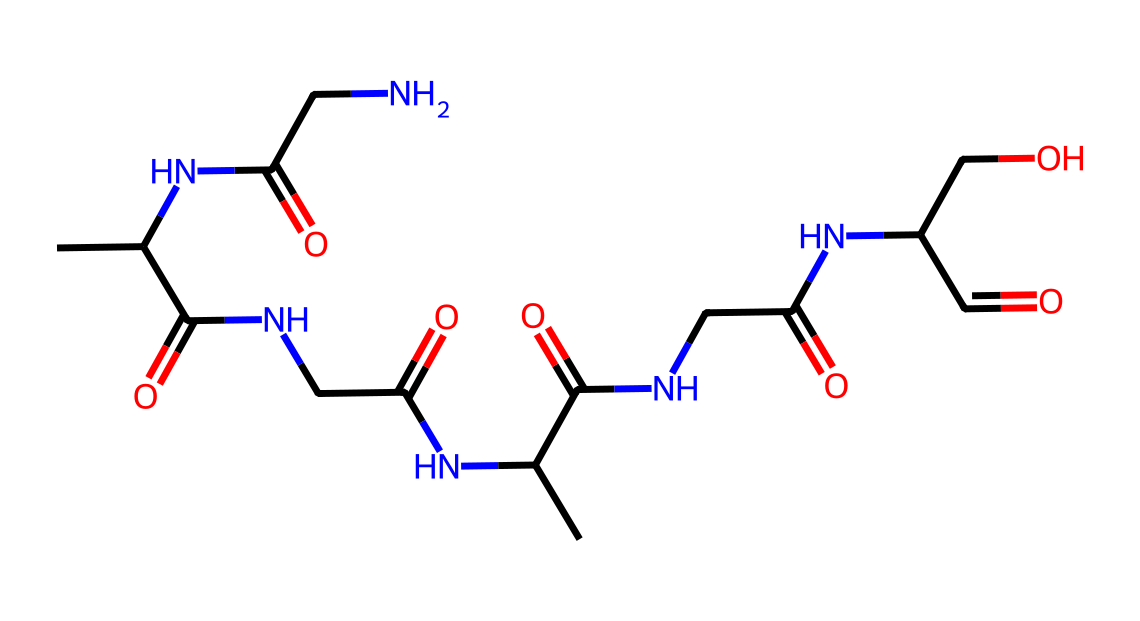What is the main functional group present in this chemical structure? The presence of the amide linkages (noted as -CONH-) indicates that the main functional group in this chemical is the amide functional group, structurally represented as alternating carbonyl and nitrogen.
Answer: amide How many nitrogen atoms are present in the structure? By examining the structure, we can count the nitrogen atoms within the amide linkages; there are six nitrogen atoms in total.
Answer: six What type of biomolecule does this structure represent? Considering the repeating units of amino acids connected by peptide bonds in the given structure, it represents a protein biomolecule.
Answer: protein What is the significance of the hydroxyl group in this structure? The hydroxyl group (-OH) present in the structure increases hydrophilicity, contributing to silk's properties such as moisture retention and dye affinity, important for its functional characteristics.
Answer: hydrophilicity How many carbon atoms are in this chemical structure? By analyzing the entire structure, we can count the carbon atoms, which adds up to twenty-two carbon atoms in total.
Answer: twenty-two Which type of bonding is primarily responsible for the silk's tensile strength? The extensive hydrogen bonding present within the silk protein contributes significantly to its tensile strength, allowing for durability and elasticity.
Answer: hydrogen bonding 